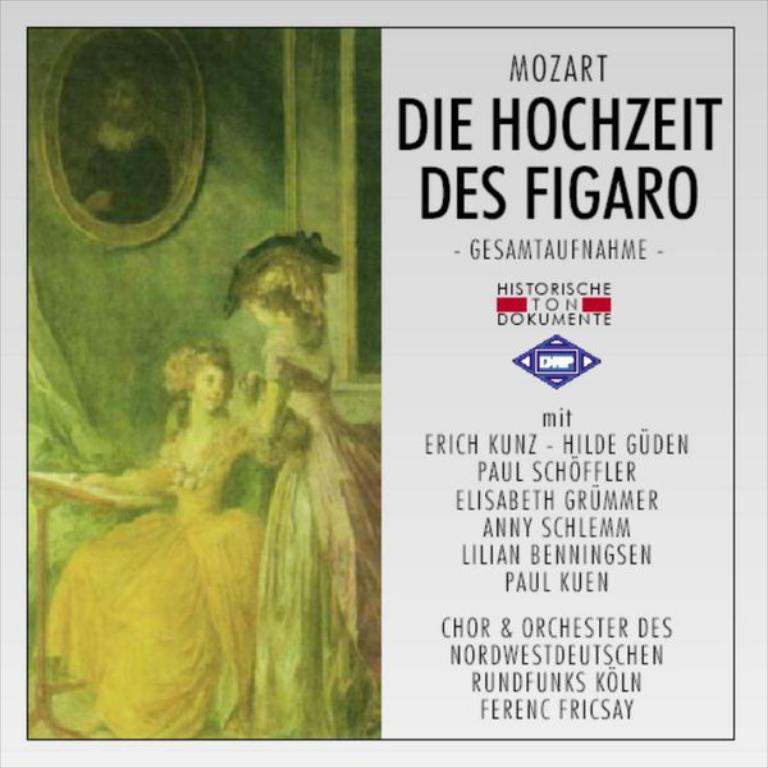<image>
Give a short and clear explanation of the subsequent image. A poster for Mozart feature two woman in victorian dresses 